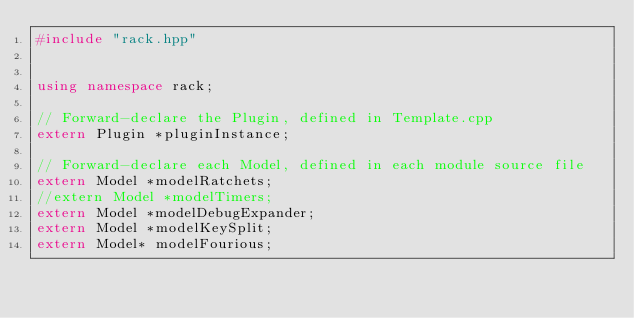Convert code to text. <code><loc_0><loc_0><loc_500><loc_500><_C++_>#include "rack.hpp"


using namespace rack;

// Forward-declare the Plugin, defined in Template.cpp
extern Plugin *pluginInstance;

// Forward-declare each Model, defined in each module source file
extern Model *modelRatchets;
//extern Model *modelTimers;
extern Model *modelDebugExpander;
extern Model *modelKeySplit;
extern Model* modelFourious;

</code> 